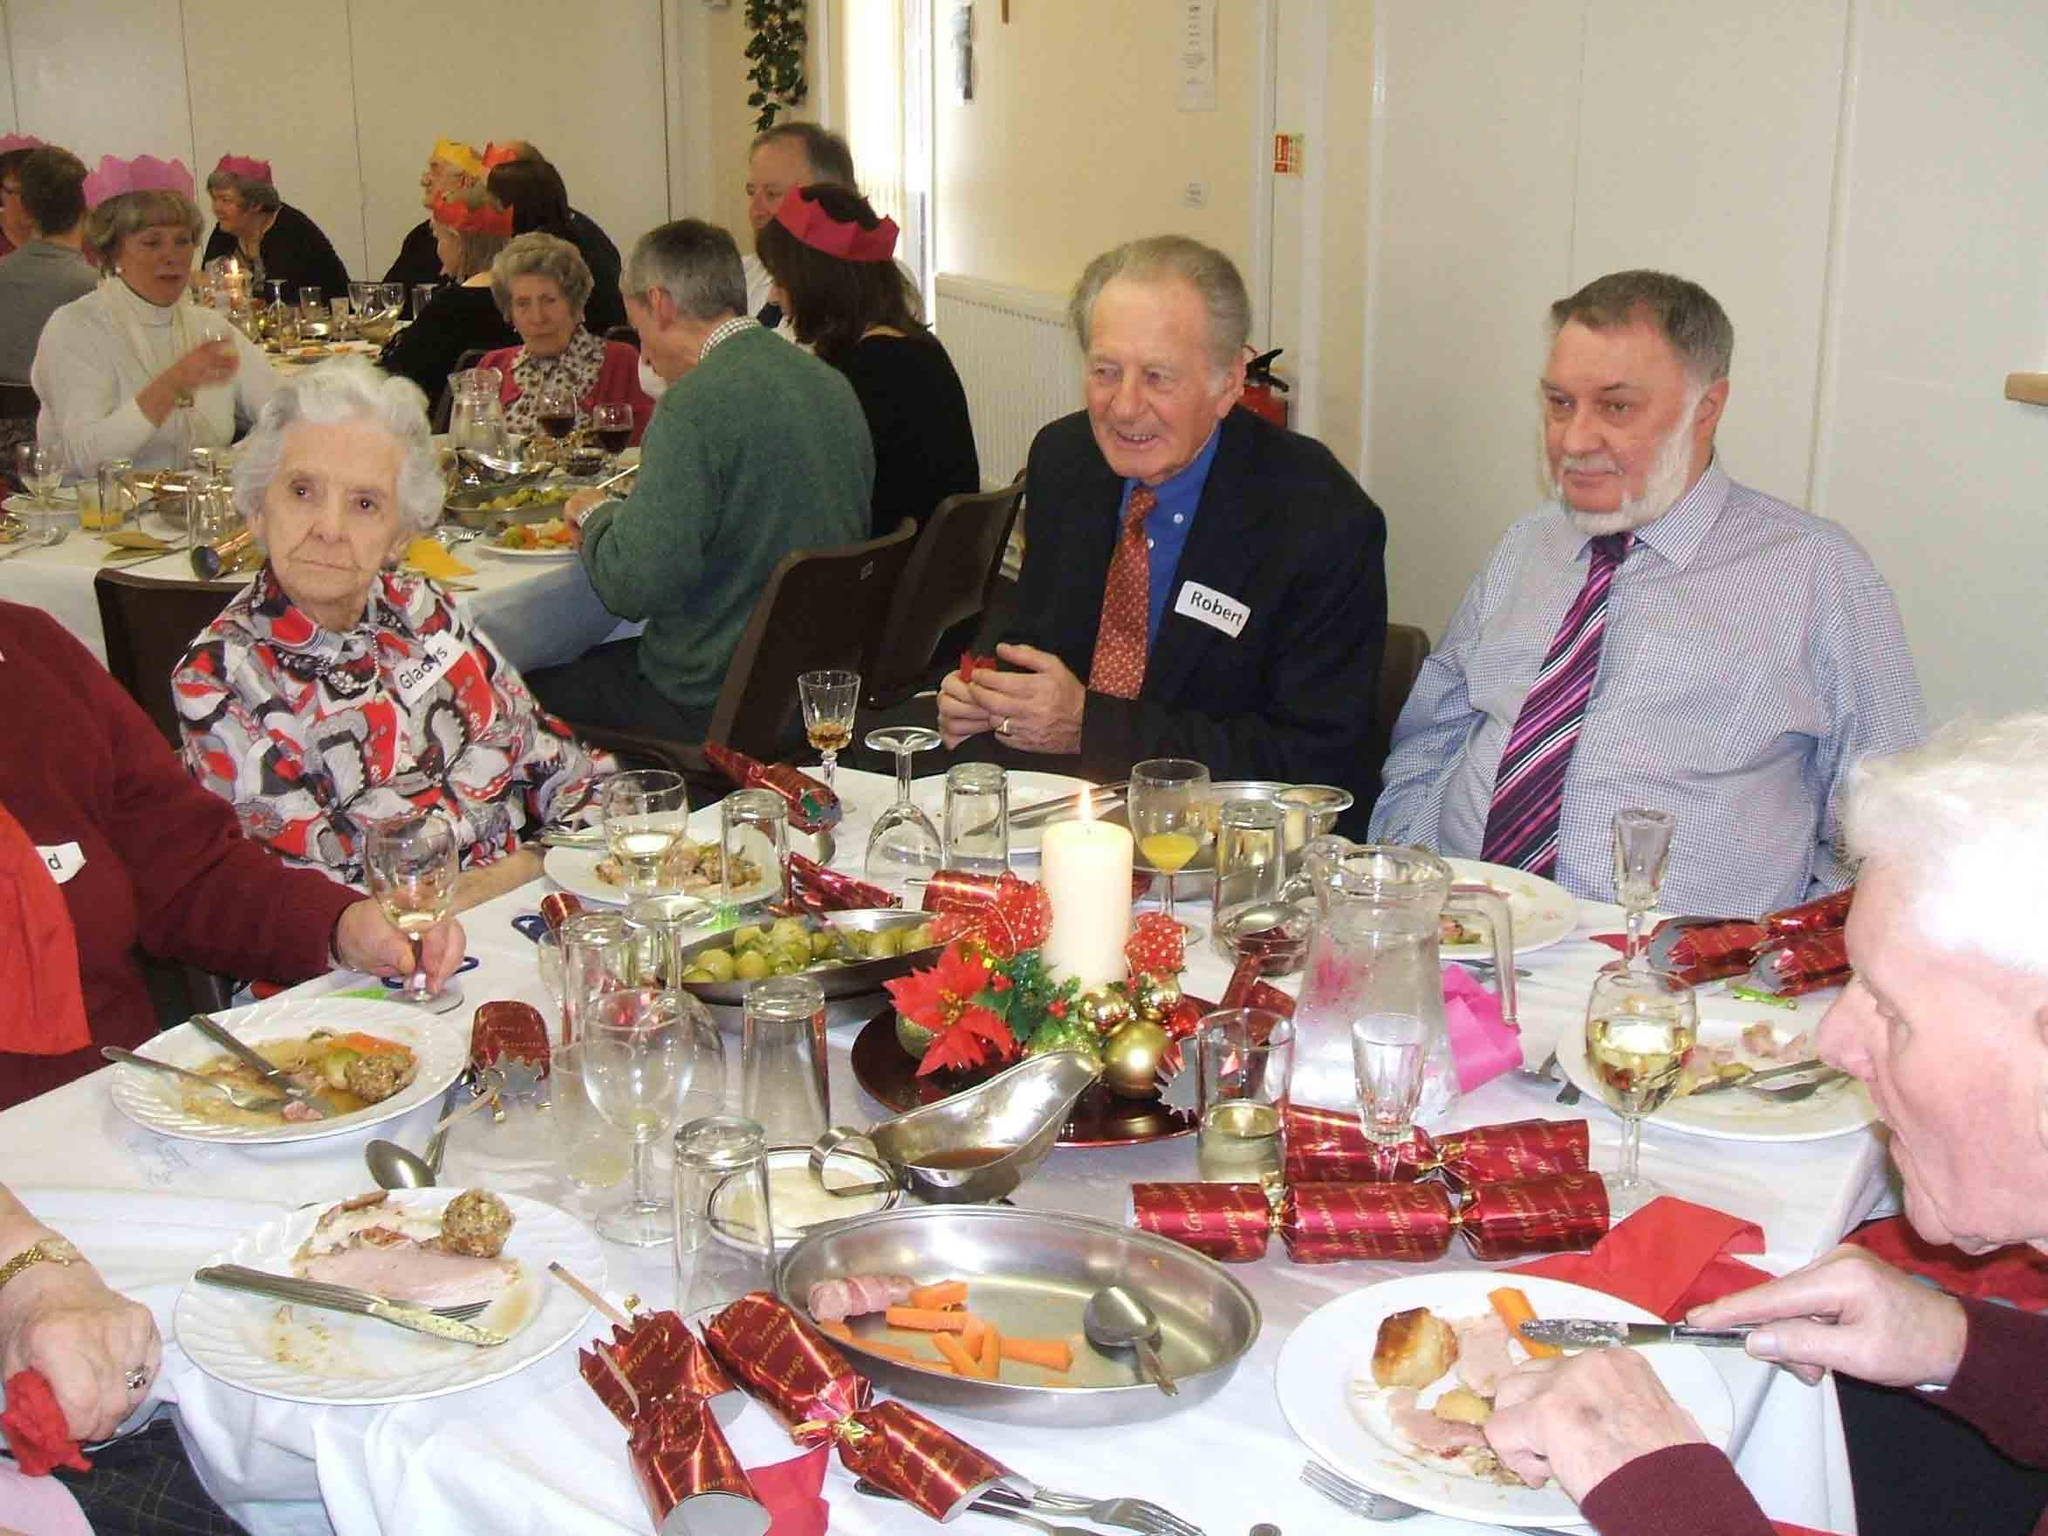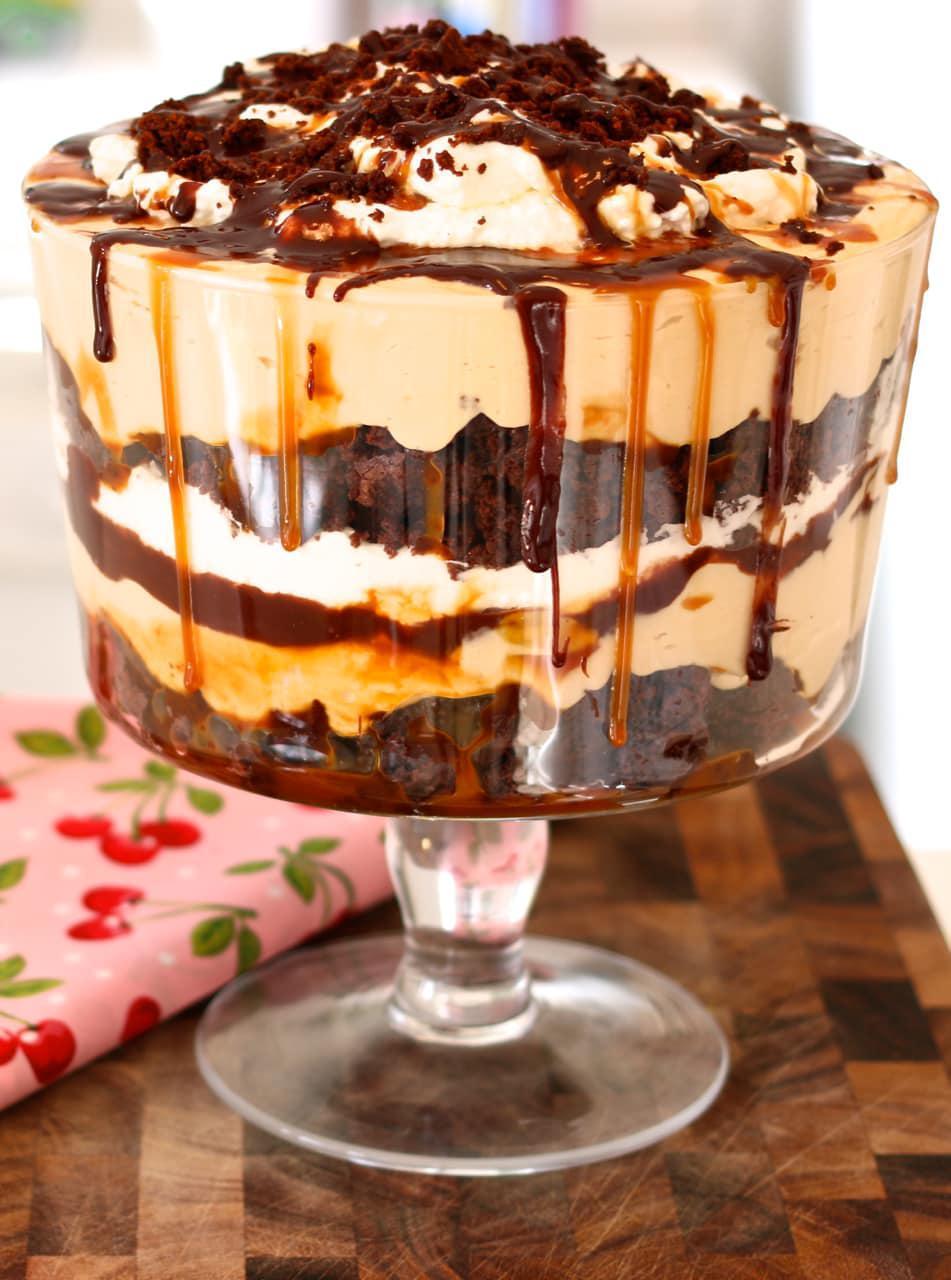The first image is the image on the left, the second image is the image on the right. Given the left and right images, does the statement "Two large trifle desserts are made in clear bowls with chocolate and creamy layers, ending with garnished creamy topping." hold true? Answer yes or no. No. 